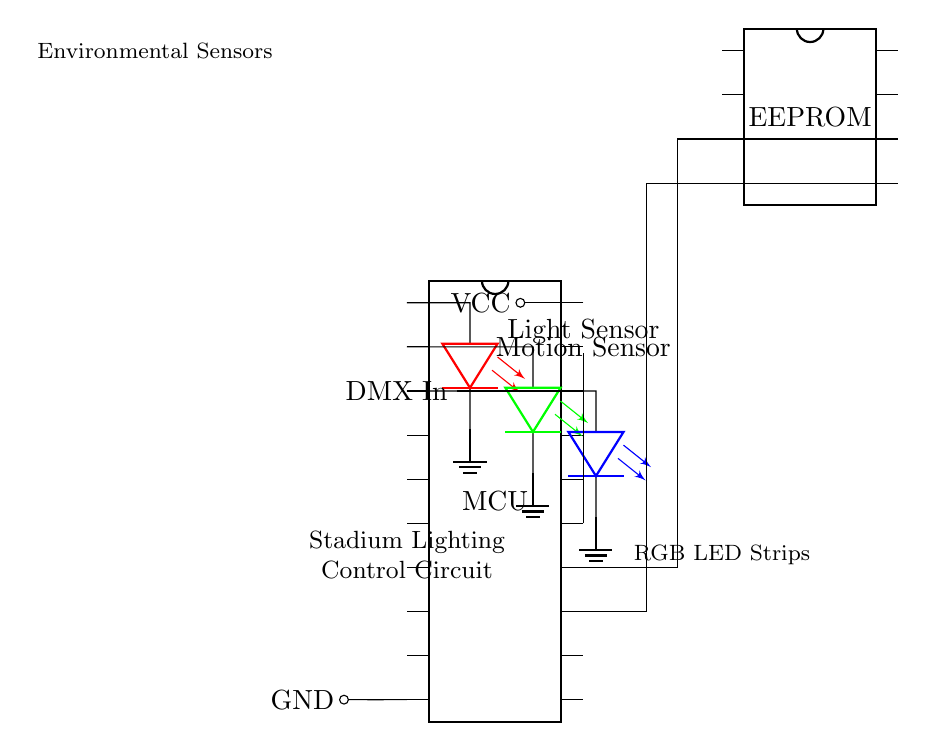What is the main component of this circuit? The main component is the microcontroller (MCU), which coordinates the operation of the lighting system.
Answer: microcontroller How many LED strips are connected? There are three LED strips connected, indicated by the three separate LED symbols in red, green, and blue.
Answer: three What type of sensors are present in the circuit? The circuit includes a light sensor and a motion sensor, which are connected to the microcontroller for monitoring environmental conditions.
Answer: light sensor and motion sensor What is the purpose of the EEPROM in this circuit? The EEPROM provides external memory for storing settings or data related to the lighting control, allowing for persistent storage beyond the microcontroller's limited internal memory.
Answer: external memory Through which pin does the DMX input connect to the microcontroller? The DMX input connects to pin eighteen (18) of the microcontroller, as indicated in the diagram.
Answer: pin eighteen How does the circuit provide power to the components? The circuit provides power through the VCC and GND connections, which are connected to pin twenty (20) and pin ten (10) of the microcontroller, respectively, supplying necessary voltage and grounding.
Answer: VCC and GND What color is the LED connected to pin 2 of the microcontroller? The LED connected to pin two (2) is green, as indicated by the color of the LED symbol in the diagram.
Answer: green 